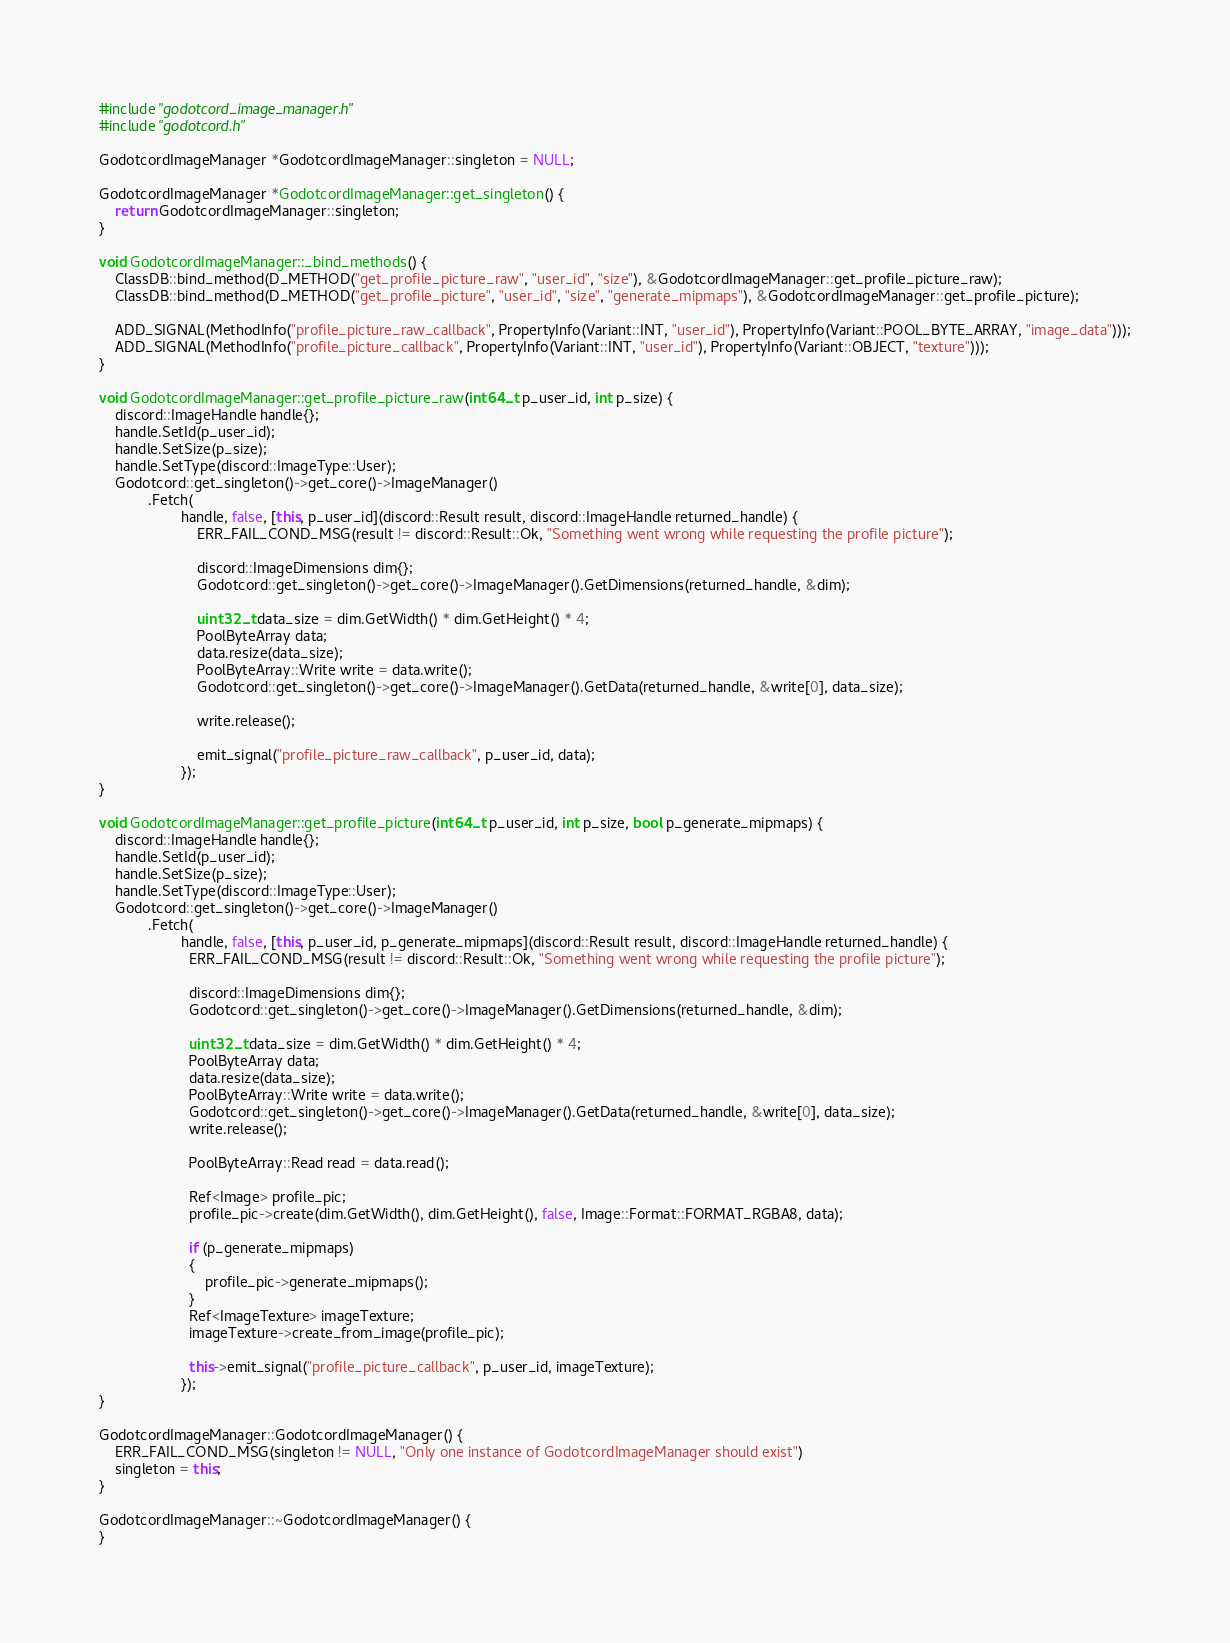<code> <loc_0><loc_0><loc_500><loc_500><_C++_>#include "godotcord_image_manager.h"
#include "godotcord.h"

GodotcordImageManager *GodotcordImageManager::singleton = NULL;

GodotcordImageManager *GodotcordImageManager::get_singleton() {
	return GodotcordImageManager::singleton;
}

void GodotcordImageManager::_bind_methods() {
	ClassDB::bind_method(D_METHOD("get_profile_picture_raw", "user_id", "size"), &GodotcordImageManager::get_profile_picture_raw);
	ClassDB::bind_method(D_METHOD("get_profile_picture", "user_id", "size", "generate_mipmaps"), &GodotcordImageManager::get_profile_picture);

	ADD_SIGNAL(MethodInfo("profile_picture_raw_callback", PropertyInfo(Variant::INT, "user_id"), PropertyInfo(Variant::POOL_BYTE_ARRAY, "image_data")));
	ADD_SIGNAL(MethodInfo("profile_picture_callback", PropertyInfo(Variant::INT, "user_id"), PropertyInfo(Variant::OBJECT, "texture")));
}

void GodotcordImageManager::get_profile_picture_raw(int64_t p_user_id, int p_size) {
	discord::ImageHandle handle{};
	handle.SetId(p_user_id);
	handle.SetSize(p_size);
	handle.SetType(discord::ImageType::User);
	Godotcord::get_singleton()->get_core()->ImageManager()
			.Fetch(
					handle, false, [this, p_user_id](discord::Result result, discord::ImageHandle returned_handle) {
						ERR_FAIL_COND_MSG(result != discord::Result::Ok, "Something went wrong while requesting the profile picture");

						discord::ImageDimensions dim{};
						Godotcord::get_singleton()->get_core()->ImageManager().GetDimensions(returned_handle, &dim);

						uint32_t data_size = dim.GetWidth() * dim.GetHeight() * 4;
						PoolByteArray data;
						data.resize(data_size);
						PoolByteArray::Write write = data.write();
						Godotcord::get_singleton()->get_core()->ImageManager().GetData(returned_handle, &write[0], data_size);

						write.release();

						emit_signal("profile_picture_raw_callback", p_user_id, data);
					});
}

void GodotcordImageManager::get_profile_picture(int64_t p_user_id, int p_size, bool p_generate_mipmaps) {
	discord::ImageHandle handle{};
	handle.SetId(p_user_id);
	handle.SetSize(p_size);
	handle.SetType(discord::ImageType::User);
	Godotcord::get_singleton()->get_core()->ImageManager()
			.Fetch(
					handle, false, [this, p_user_id, p_generate_mipmaps](discord::Result result, discord::ImageHandle returned_handle) {
					  ERR_FAIL_COND_MSG(result != discord::Result::Ok, "Something went wrong while requesting the profile picture");

					  discord::ImageDimensions dim{};
					  Godotcord::get_singleton()->get_core()->ImageManager().GetDimensions(returned_handle, &dim);

					  uint32_t data_size = dim.GetWidth() * dim.GetHeight() * 4;
					  PoolByteArray data;
					  data.resize(data_size);
					  PoolByteArray::Write write = data.write();
					  Godotcord::get_singleton()->get_core()->ImageManager().GetData(returned_handle, &write[0], data_size);
					  write.release();

					  PoolByteArray::Read read = data.read();

					  Ref<Image> profile_pic;
					  profile_pic->create(dim.GetWidth(), dim.GetHeight(), false, Image::Format::FORMAT_RGBA8, data);

					  if (p_generate_mipmaps)
					  {
						  profile_pic->generate_mipmaps();
					  }
					  Ref<ImageTexture> imageTexture;
					  imageTexture->create_from_image(profile_pic);

					  this->emit_signal("profile_picture_callback", p_user_id, imageTexture);
					});
}

GodotcordImageManager::GodotcordImageManager() {
	ERR_FAIL_COND_MSG(singleton != NULL, "Only one instance of GodotcordImageManager should exist")
	singleton = this;
}

GodotcordImageManager::~GodotcordImageManager() {
}
</code> 